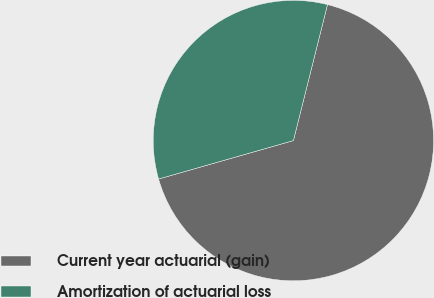<chart> <loc_0><loc_0><loc_500><loc_500><pie_chart><fcel>Current year actuarial (gain)<fcel>Amortization of actuarial loss<nl><fcel>66.67%<fcel>33.33%<nl></chart> 